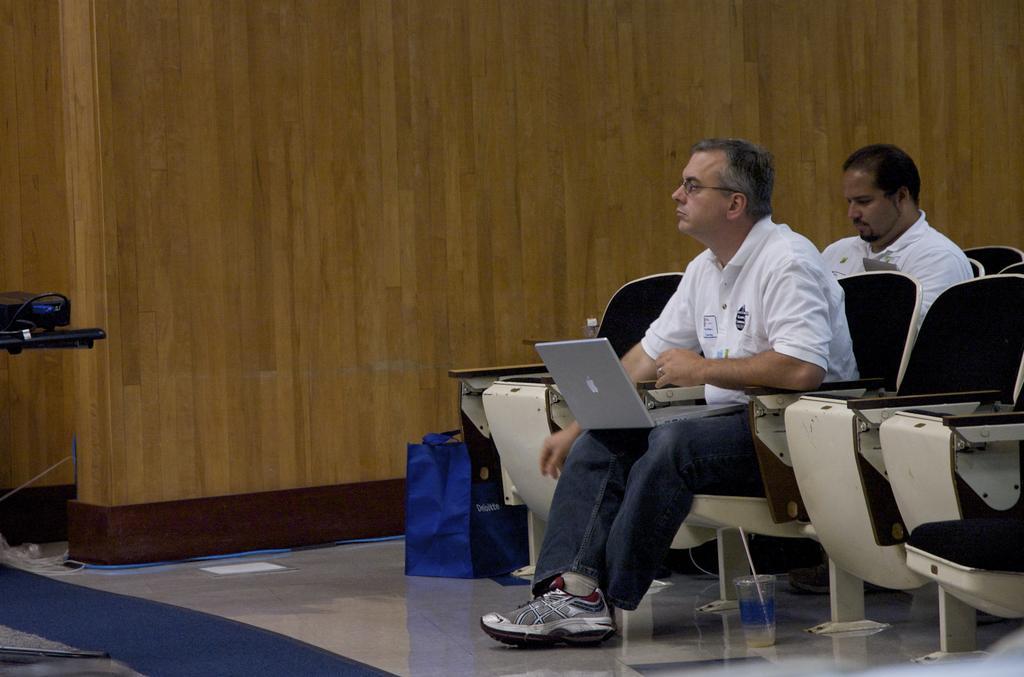How would you summarize this image in a sentence or two? In this picture we can see two men, they are sitting on the chairs, in front of them we can see a laptop, glass and a bag. 